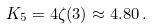<formula> <loc_0><loc_0><loc_500><loc_500>K _ { 5 } = 4 \zeta ( 3 ) \approx 4 . 8 0 \, .</formula> 